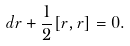Convert formula to latex. <formula><loc_0><loc_0><loc_500><loc_500>d r + \frac { 1 } { 2 } [ r , r ] = 0 .</formula> 